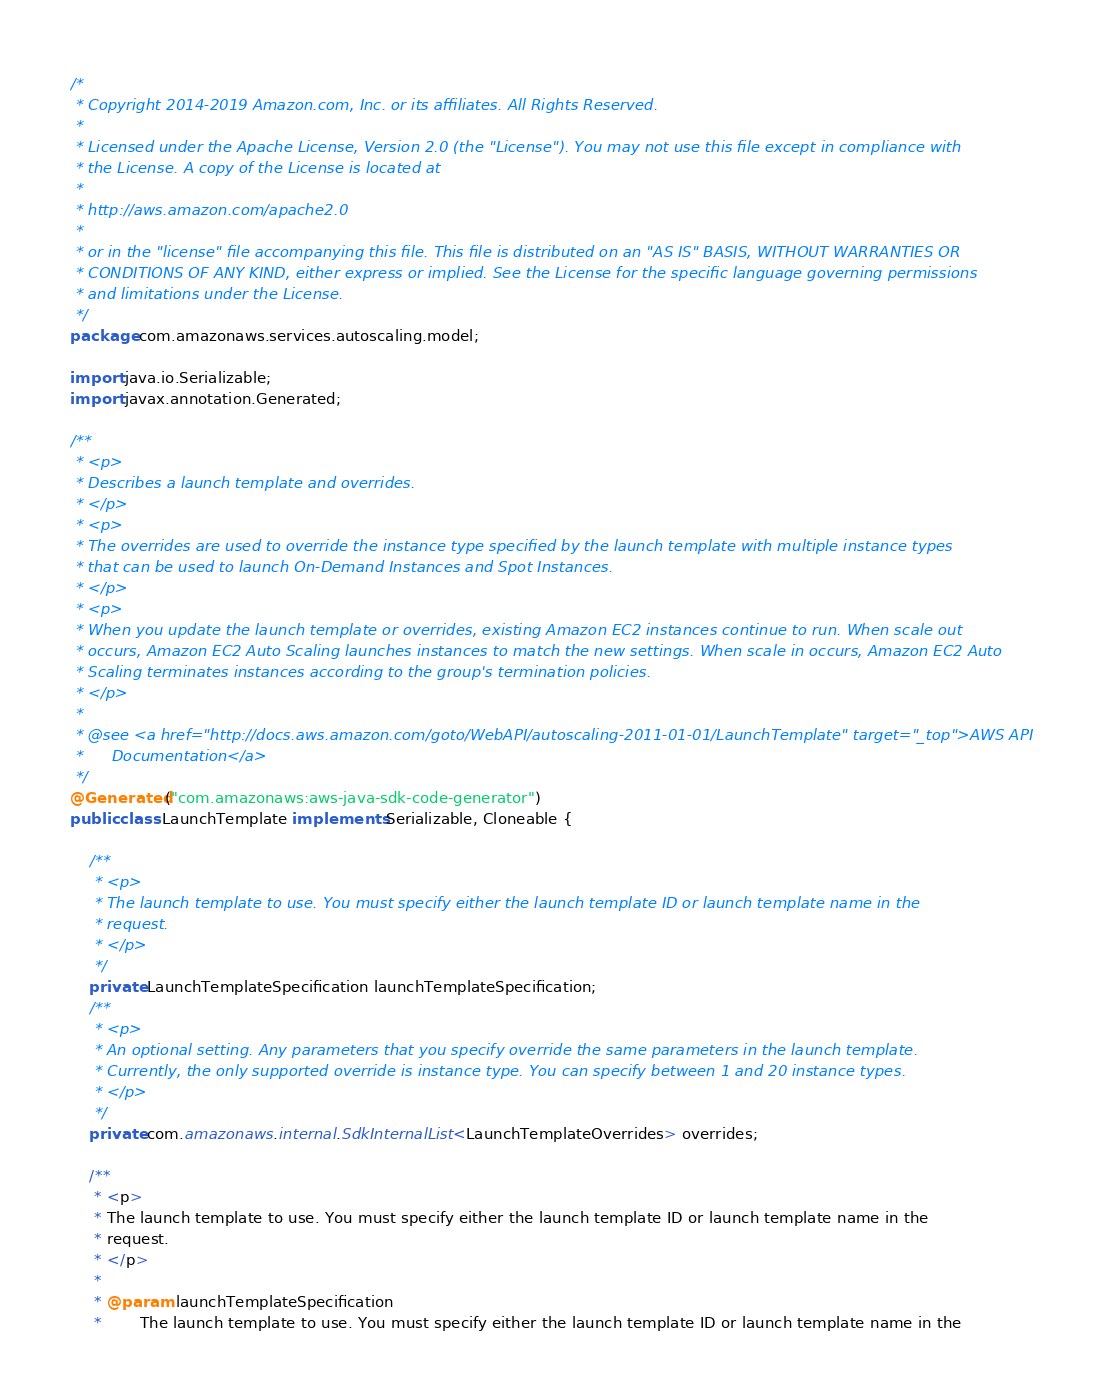<code> <loc_0><loc_0><loc_500><loc_500><_Java_>/*
 * Copyright 2014-2019 Amazon.com, Inc. or its affiliates. All Rights Reserved.
 * 
 * Licensed under the Apache License, Version 2.0 (the "License"). You may not use this file except in compliance with
 * the License. A copy of the License is located at
 * 
 * http://aws.amazon.com/apache2.0
 * 
 * or in the "license" file accompanying this file. This file is distributed on an "AS IS" BASIS, WITHOUT WARRANTIES OR
 * CONDITIONS OF ANY KIND, either express or implied. See the License for the specific language governing permissions
 * and limitations under the License.
 */
package com.amazonaws.services.autoscaling.model;

import java.io.Serializable;
import javax.annotation.Generated;

/**
 * <p>
 * Describes a launch template and overrides.
 * </p>
 * <p>
 * The overrides are used to override the instance type specified by the launch template with multiple instance types
 * that can be used to launch On-Demand Instances and Spot Instances.
 * </p>
 * <p>
 * When you update the launch template or overrides, existing Amazon EC2 instances continue to run. When scale out
 * occurs, Amazon EC2 Auto Scaling launches instances to match the new settings. When scale in occurs, Amazon EC2 Auto
 * Scaling terminates instances according to the group's termination policies.
 * </p>
 * 
 * @see <a href="http://docs.aws.amazon.com/goto/WebAPI/autoscaling-2011-01-01/LaunchTemplate" target="_top">AWS API
 *      Documentation</a>
 */
@Generated("com.amazonaws:aws-java-sdk-code-generator")
public class LaunchTemplate implements Serializable, Cloneable {

    /**
     * <p>
     * The launch template to use. You must specify either the launch template ID or launch template name in the
     * request.
     * </p>
     */
    private LaunchTemplateSpecification launchTemplateSpecification;
    /**
     * <p>
     * An optional setting. Any parameters that you specify override the same parameters in the launch template.
     * Currently, the only supported override is instance type. You can specify between 1 and 20 instance types.
     * </p>
     */
    private com.amazonaws.internal.SdkInternalList<LaunchTemplateOverrides> overrides;

    /**
     * <p>
     * The launch template to use. You must specify either the launch template ID or launch template name in the
     * request.
     * </p>
     * 
     * @param launchTemplateSpecification
     *        The launch template to use. You must specify either the launch template ID or launch template name in the</code> 